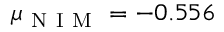<formula> <loc_0><loc_0><loc_500><loc_500>\mu _ { N I M } = - 0 . 5 5 6</formula> 